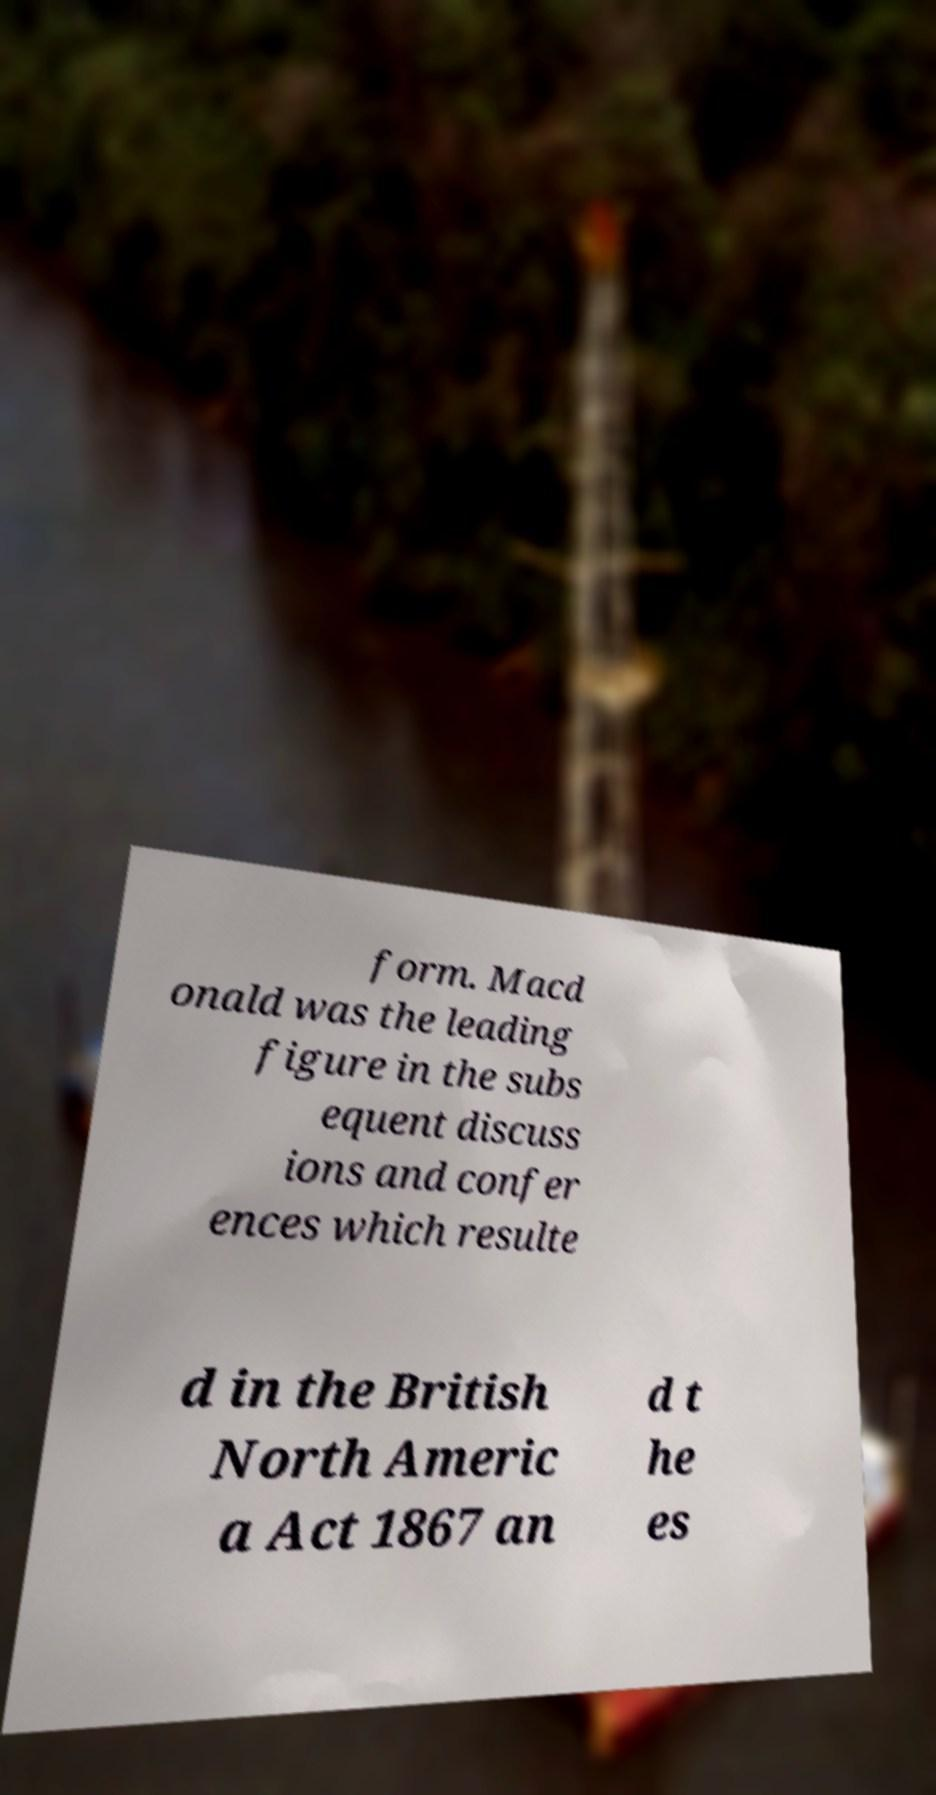Please identify and transcribe the text found in this image. form. Macd onald was the leading figure in the subs equent discuss ions and confer ences which resulte d in the British North Americ a Act 1867 an d t he es 